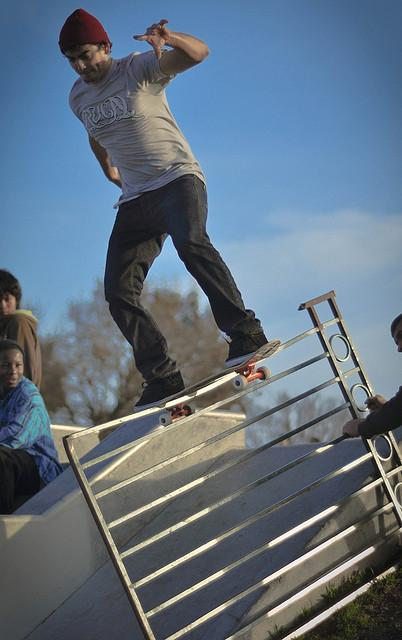Why is the man on top of the railing?

Choices:
A) to wax
B) to grind
C) to flip
D) to clean to grind 